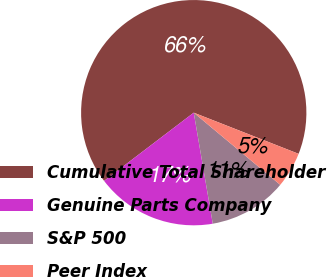<chart> <loc_0><loc_0><loc_500><loc_500><pie_chart><fcel>Cumulative Total Shareholder<fcel>Genuine Parts Company<fcel>S&P 500<fcel>Peer Index<nl><fcel>66.3%<fcel>17.35%<fcel>11.23%<fcel>5.11%<nl></chart> 